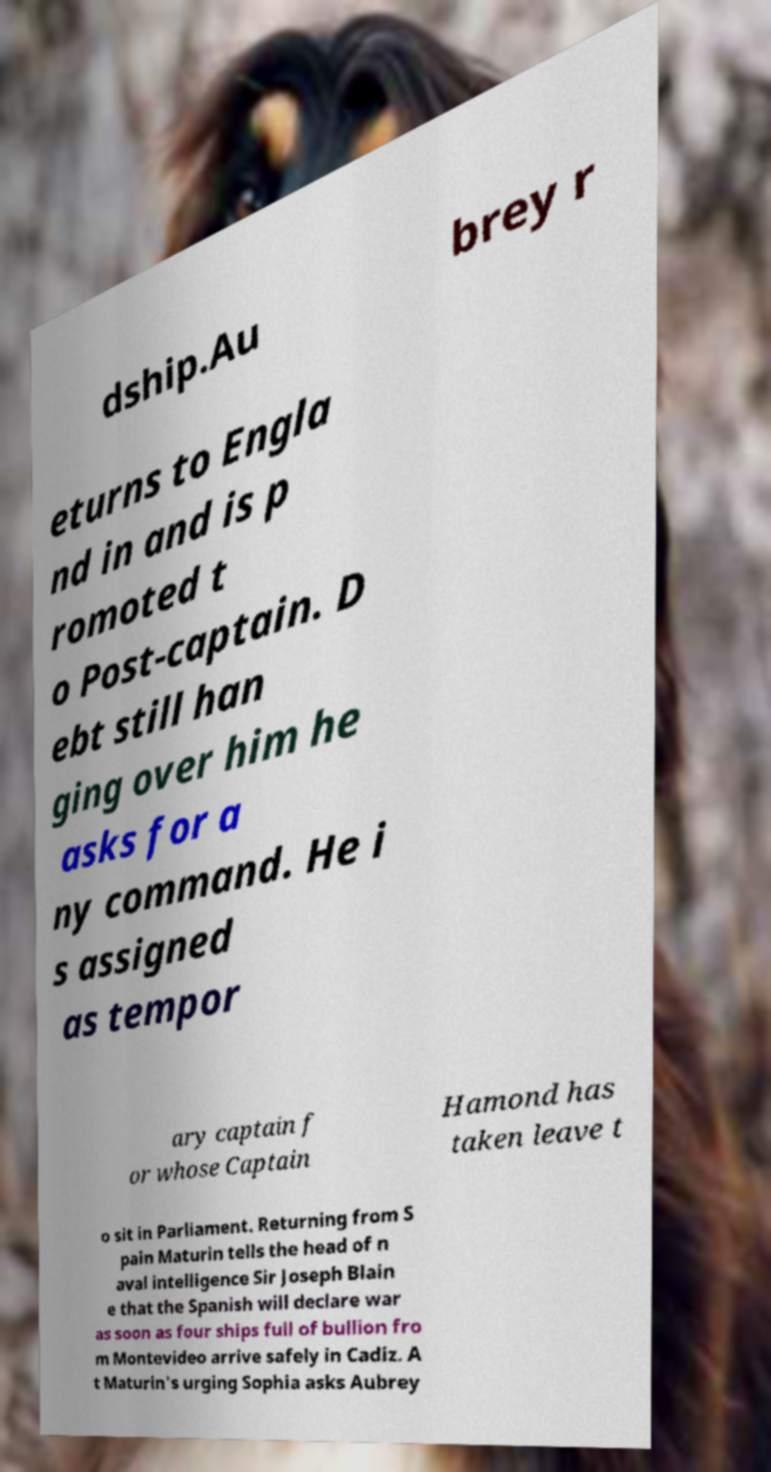For documentation purposes, I need the text within this image transcribed. Could you provide that? dship.Au brey r eturns to Engla nd in and is p romoted t o Post-captain. D ebt still han ging over him he asks for a ny command. He i s assigned as tempor ary captain f or whose Captain Hamond has taken leave t o sit in Parliament. Returning from S pain Maturin tells the head of n aval intelligence Sir Joseph Blain e that the Spanish will declare war as soon as four ships full of bullion fro m Montevideo arrive safely in Cadiz. A t Maturin's urging Sophia asks Aubrey 